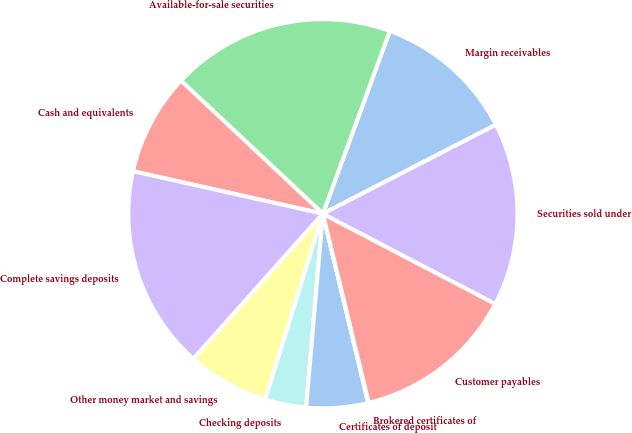Convert chart. <chart><loc_0><loc_0><loc_500><loc_500><pie_chart><fcel>Margin receivables<fcel>Available-for-sale securities<fcel>Cash and equivalents<fcel>Complete savings deposits<fcel>Other money market and savings<fcel>Checking deposits<fcel>Certificates of deposit<fcel>Brokered certificates of<fcel>Customer payables<fcel>Securities sold under<nl><fcel>11.85%<fcel>18.6%<fcel>8.48%<fcel>16.91%<fcel>6.8%<fcel>3.42%<fcel>5.11%<fcel>0.05%<fcel>13.54%<fcel>15.23%<nl></chart> 